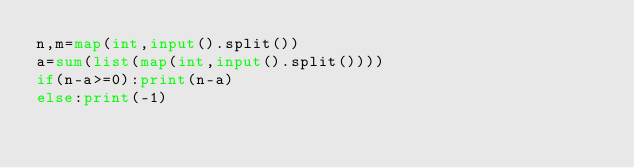Convert code to text. <code><loc_0><loc_0><loc_500><loc_500><_Python_>n,m=map(int,input().split())
a=sum(list(map(int,input().split())))
if(n-a>=0):print(n-a)
else:print(-1)</code> 